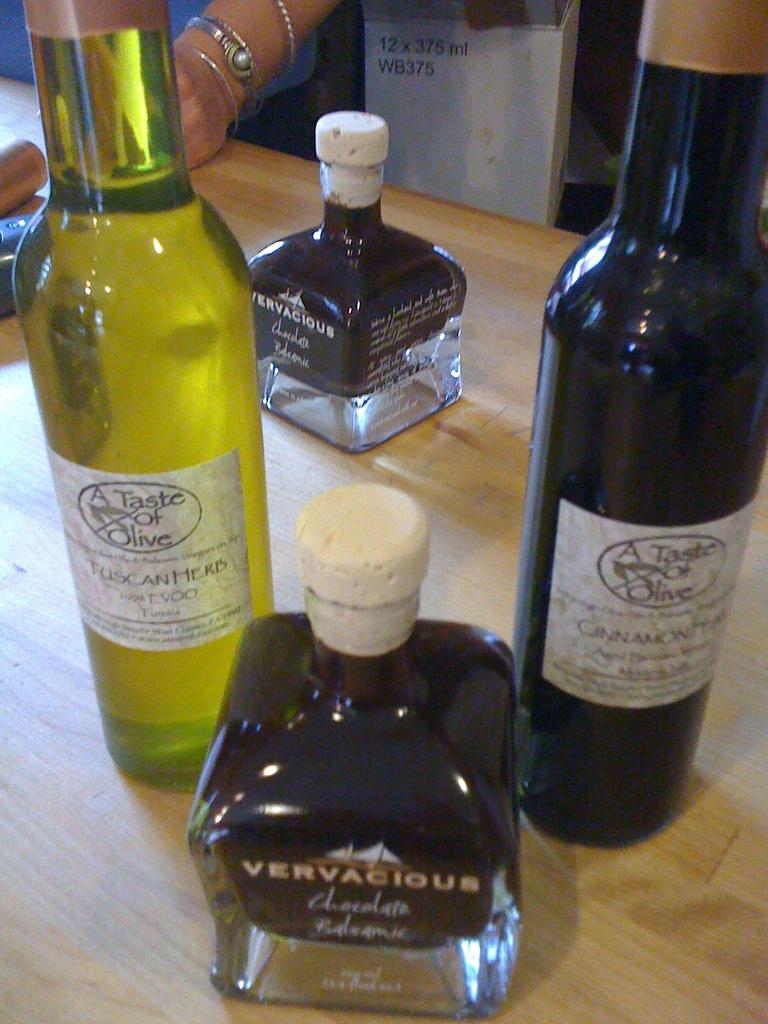What is the brand name of the bottle in the front?
Make the answer very short. Vervacious. 